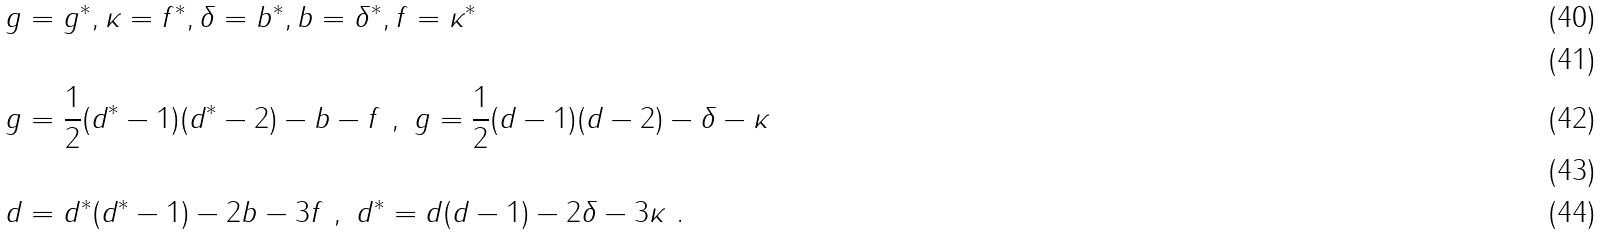<formula> <loc_0><loc_0><loc_500><loc_500>& g = g ^ { * } , \kappa = f ^ { * } , \delta = b ^ { * } , b = \delta ^ { * } , f = \kappa ^ { * } \\ \ \\ & g = \frac { 1 } { 2 } ( d ^ { * } - 1 ) ( d ^ { * } - 2 ) - b - f \ , \ g = \frac { 1 } { 2 } ( d - 1 ) ( d - 2 ) - \delta - \kappa \\ \ \\ & d = d ^ { * } ( d ^ { * } - 1 ) - 2 b - 3 f \ , \ d ^ { * } = d ( d - 1 ) - 2 \delta - 3 \kappa \ .</formula> 